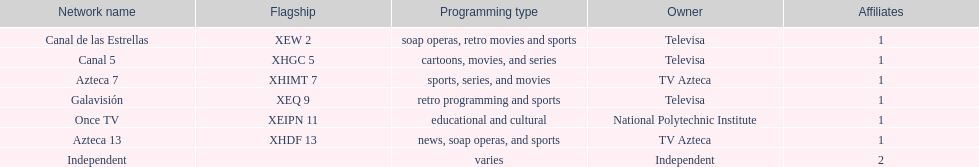How many networks does televisa possess? 3. 